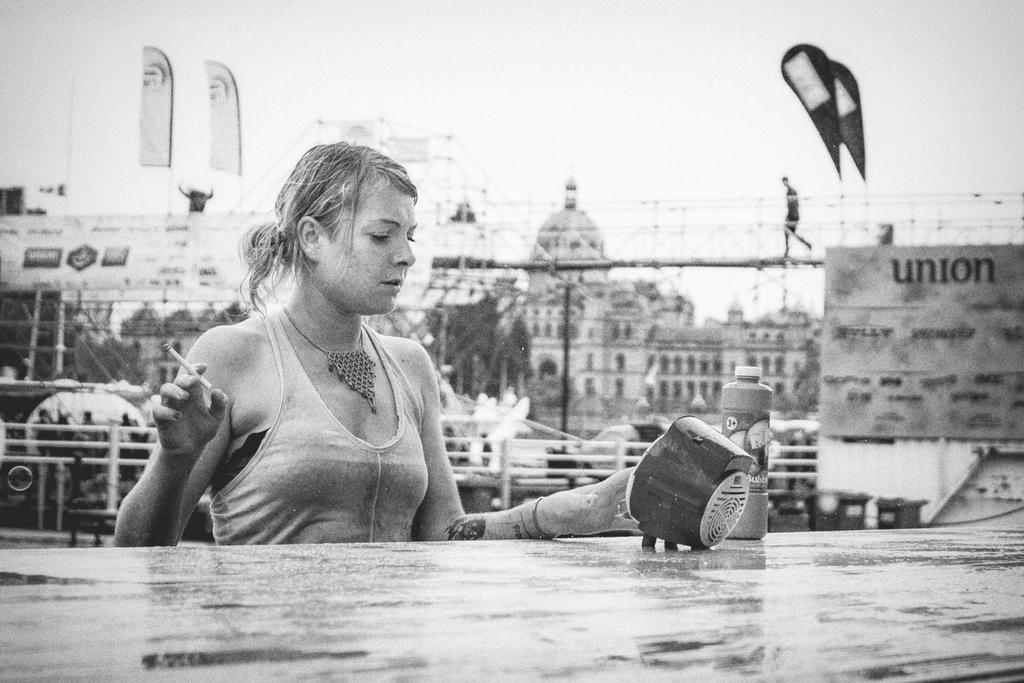What type of structures can be seen in the image? There are buildings in the image. What is located near the buildings? There is a fence in the image. What piece of furniture is present in the image? There is a table in the image. Who is standing near the table? There is a lady present in front of the table. What is the lady holding in her hand? The lady is holding a cigarette. What object is on the table? There is a box on the table. What type of bread is the man eating in the image? There is no man present in the image, and therefore no one is eating bread. 